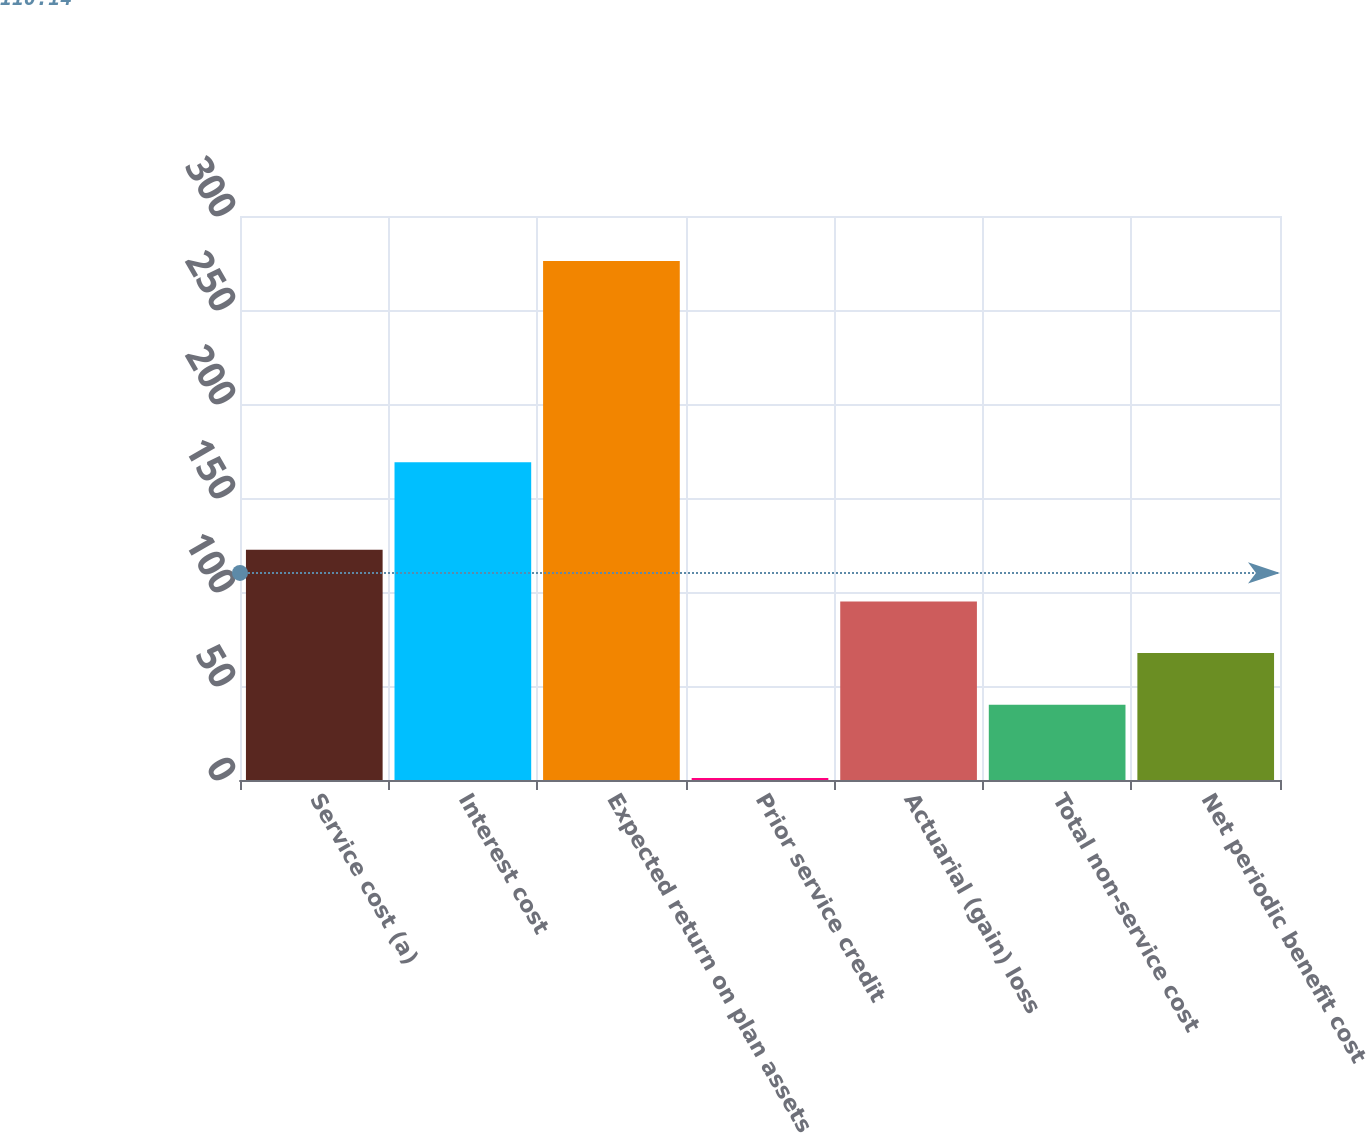Convert chart. <chart><loc_0><loc_0><loc_500><loc_500><bar_chart><fcel>Service cost (a)<fcel>Interest cost<fcel>Expected return on plan assets<fcel>Prior service credit<fcel>Actuarial (gain) loss<fcel>Total non-service cost<fcel>Net periodic benefit cost<nl><fcel>122.5<fcel>169<fcel>276<fcel>1<fcel>95<fcel>40<fcel>67.5<nl></chart> 